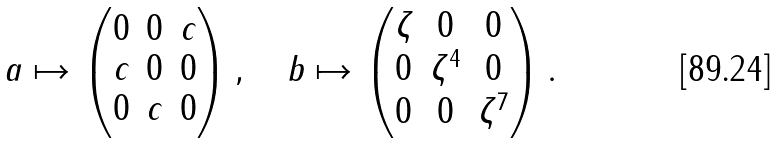<formula> <loc_0><loc_0><loc_500><loc_500>a \mapsto \begin{pmatrix} 0 & 0 & c \\ c & 0 & 0 \\ 0 & c & 0 \end{pmatrix} , \quad b \mapsto \begin{pmatrix} \zeta & 0 & 0 \\ 0 & \zeta ^ { 4 } & 0 \\ 0 & 0 & \zeta ^ { 7 } \end{pmatrix} .</formula> 